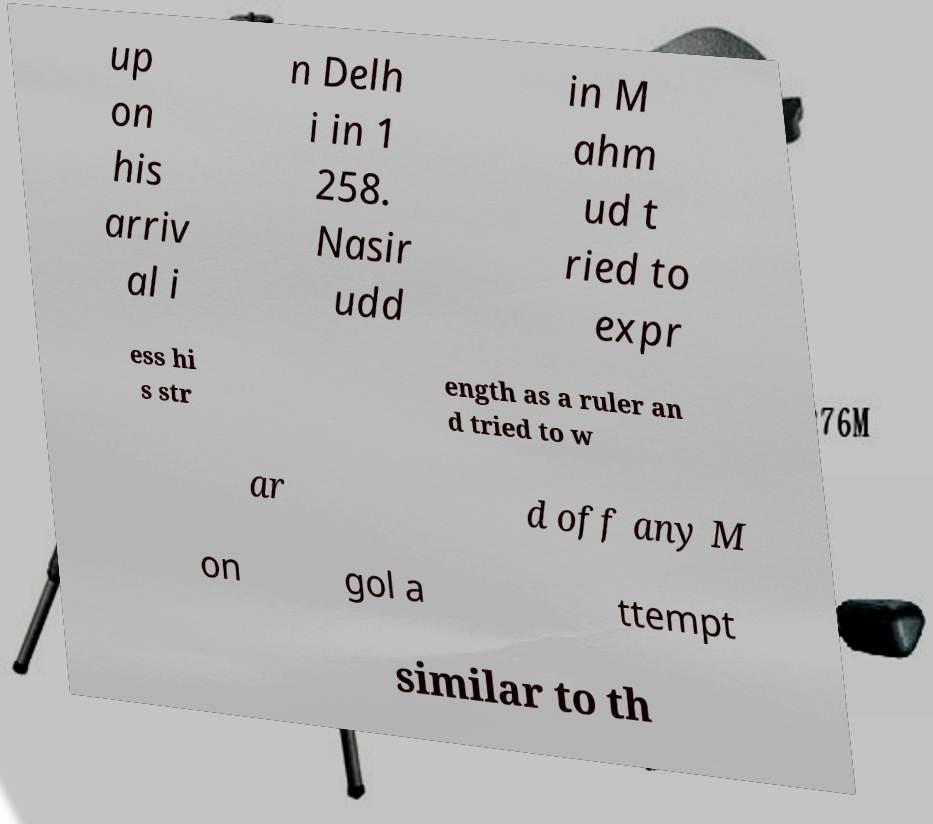For documentation purposes, I need the text within this image transcribed. Could you provide that? up on his arriv al i n Delh i in 1 258. Nasir udd in M ahm ud t ried to expr ess hi s str ength as a ruler an d tried to w ar d off any M on gol a ttempt similar to th 